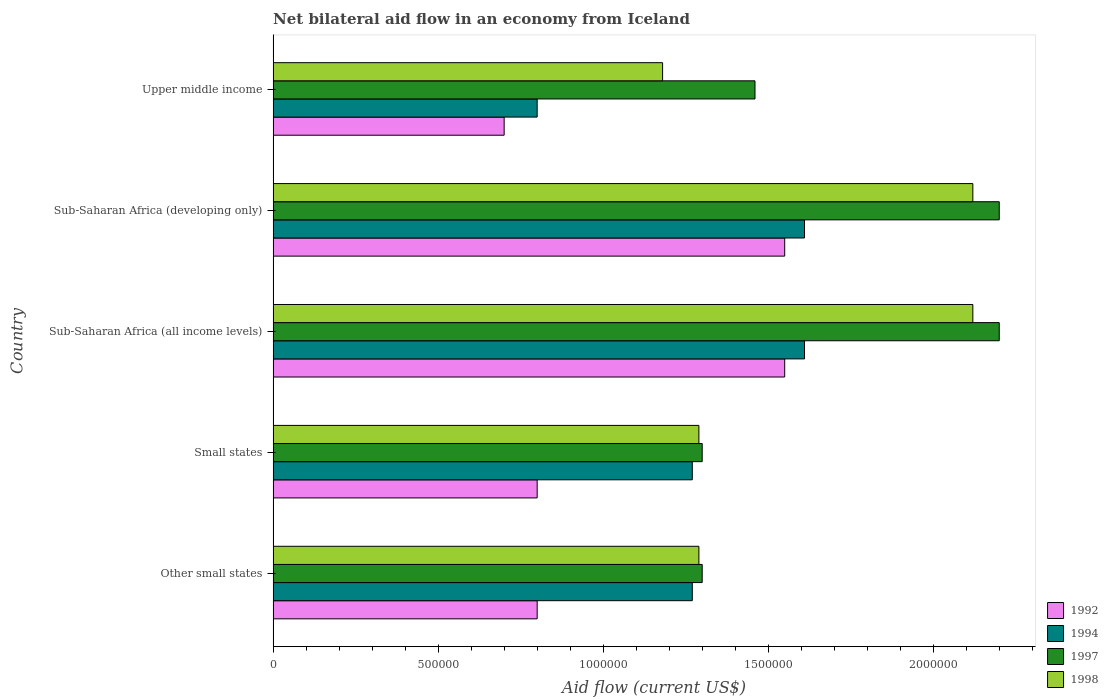How many different coloured bars are there?
Offer a very short reply. 4. How many bars are there on the 2nd tick from the top?
Give a very brief answer. 4. What is the label of the 3rd group of bars from the top?
Provide a succinct answer. Sub-Saharan Africa (all income levels). In how many cases, is the number of bars for a given country not equal to the number of legend labels?
Provide a short and direct response. 0. What is the net bilateral aid flow in 1994 in Upper middle income?
Ensure brevity in your answer.  8.00e+05. Across all countries, what is the maximum net bilateral aid flow in 1994?
Keep it short and to the point. 1.61e+06. Across all countries, what is the minimum net bilateral aid flow in 1997?
Ensure brevity in your answer.  1.30e+06. In which country was the net bilateral aid flow in 1992 maximum?
Make the answer very short. Sub-Saharan Africa (all income levels). In which country was the net bilateral aid flow in 1994 minimum?
Your response must be concise. Upper middle income. What is the total net bilateral aid flow in 1994 in the graph?
Offer a very short reply. 6.56e+06. What is the difference between the net bilateral aid flow in 1998 in Sub-Saharan Africa (developing only) and the net bilateral aid flow in 1992 in Other small states?
Ensure brevity in your answer.  1.32e+06. What is the average net bilateral aid flow in 1997 per country?
Ensure brevity in your answer.  1.69e+06. What is the difference between the net bilateral aid flow in 1997 and net bilateral aid flow in 1992 in Sub-Saharan Africa (all income levels)?
Provide a succinct answer. 6.50e+05. In how many countries, is the net bilateral aid flow in 1992 greater than 2100000 US$?
Make the answer very short. 0. What is the ratio of the net bilateral aid flow in 1992 in Small states to that in Sub-Saharan Africa (all income levels)?
Your response must be concise. 0.52. Is the difference between the net bilateral aid flow in 1997 in Sub-Saharan Africa (all income levels) and Sub-Saharan Africa (developing only) greater than the difference between the net bilateral aid flow in 1992 in Sub-Saharan Africa (all income levels) and Sub-Saharan Africa (developing only)?
Offer a terse response. No. What is the difference between the highest and the second highest net bilateral aid flow in 1994?
Provide a succinct answer. 0. What is the difference between the highest and the lowest net bilateral aid flow in 1992?
Provide a succinct answer. 8.50e+05. In how many countries, is the net bilateral aid flow in 1992 greater than the average net bilateral aid flow in 1992 taken over all countries?
Provide a short and direct response. 2. What does the 3rd bar from the top in Upper middle income represents?
Give a very brief answer. 1994. What does the 1st bar from the bottom in Sub-Saharan Africa (developing only) represents?
Offer a very short reply. 1992. Are all the bars in the graph horizontal?
Ensure brevity in your answer.  Yes. What is the difference between two consecutive major ticks on the X-axis?
Your response must be concise. 5.00e+05. Are the values on the major ticks of X-axis written in scientific E-notation?
Offer a terse response. No. Does the graph contain any zero values?
Provide a succinct answer. No. Does the graph contain grids?
Provide a succinct answer. No. Where does the legend appear in the graph?
Your answer should be compact. Bottom right. How many legend labels are there?
Your answer should be compact. 4. What is the title of the graph?
Your response must be concise. Net bilateral aid flow in an economy from Iceland. Does "1999" appear as one of the legend labels in the graph?
Make the answer very short. No. What is the label or title of the X-axis?
Make the answer very short. Aid flow (current US$). What is the label or title of the Y-axis?
Ensure brevity in your answer.  Country. What is the Aid flow (current US$) in 1992 in Other small states?
Your answer should be very brief. 8.00e+05. What is the Aid flow (current US$) in 1994 in Other small states?
Your answer should be very brief. 1.27e+06. What is the Aid flow (current US$) in 1997 in Other small states?
Make the answer very short. 1.30e+06. What is the Aid flow (current US$) in 1998 in Other small states?
Your answer should be very brief. 1.29e+06. What is the Aid flow (current US$) in 1994 in Small states?
Make the answer very short. 1.27e+06. What is the Aid flow (current US$) of 1997 in Small states?
Keep it short and to the point. 1.30e+06. What is the Aid flow (current US$) in 1998 in Small states?
Offer a terse response. 1.29e+06. What is the Aid flow (current US$) in 1992 in Sub-Saharan Africa (all income levels)?
Keep it short and to the point. 1.55e+06. What is the Aid flow (current US$) in 1994 in Sub-Saharan Africa (all income levels)?
Provide a short and direct response. 1.61e+06. What is the Aid flow (current US$) in 1997 in Sub-Saharan Africa (all income levels)?
Your answer should be very brief. 2.20e+06. What is the Aid flow (current US$) in 1998 in Sub-Saharan Africa (all income levels)?
Keep it short and to the point. 2.12e+06. What is the Aid flow (current US$) in 1992 in Sub-Saharan Africa (developing only)?
Offer a terse response. 1.55e+06. What is the Aid flow (current US$) of 1994 in Sub-Saharan Africa (developing only)?
Your response must be concise. 1.61e+06. What is the Aid flow (current US$) of 1997 in Sub-Saharan Africa (developing only)?
Provide a succinct answer. 2.20e+06. What is the Aid flow (current US$) of 1998 in Sub-Saharan Africa (developing only)?
Offer a terse response. 2.12e+06. What is the Aid flow (current US$) in 1992 in Upper middle income?
Ensure brevity in your answer.  7.00e+05. What is the Aid flow (current US$) of 1994 in Upper middle income?
Keep it short and to the point. 8.00e+05. What is the Aid flow (current US$) of 1997 in Upper middle income?
Give a very brief answer. 1.46e+06. What is the Aid flow (current US$) of 1998 in Upper middle income?
Your response must be concise. 1.18e+06. Across all countries, what is the maximum Aid flow (current US$) in 1992?
Ensure brevity in your answer.  1.55e+06. Across all countries, what is the maximum Aid flow (current US$) in 1994?
Keep it short and to the point. 1.61e+06. Across all countries, what is the maximum Aid flow (current US$) in 1997?
Your answer should be very brief. 2.20e+06. Across all countries, what is the maximum Aid flow (current US$) in 1998?
Keep it short and to the point. 2.12e+06. Across all countries, what is the minimum Aid flow (current US$) in 1994?
Your response must be concise. 8.00e+05. Across all countries, what is the minimum Aid flow (current US$) in 1997?
Give a very brief answer. 1.30e+06. Across all countries, what is the minimum Aid flow (current US$) in 1998?
Offer a very short reply. 1.18e+06. What is the total Aid flow (current US$) of 1992 in the graph?
Offer a terse response. 5.40e+06. What is the total Aid flow (current US$) of 1994 in the graph?
Your answer should be compact. 6.56e+06. What is the total Aid flow (current US$) of 1997 in the graph?
Keep it short and to the point. 8.46e+06. What is the total Aid flow (current US$) in 1998 in the graph?
Provide a succinct answer. 8.00e+06. What is the difference between the Aid flow (current US$) in 1998 in Other small states and that in Small states?
Give a very brief answer. 0. What is the difference between the Aid flow (current US$) in 1992 in Other small states and that in Sub-Saharan Africa (all income levels)?
Your response must be concise. -7.50e+05. What is the difference between the Aid flow (current US$) of 1994 in Other small states and that in Sub-Saharan Africa (all income levels)?
Your answer should be compact. -3.40e+05. What is the difference between the Aid flow (current US$) in 1997 in Other small states and that in Sub-Saharan Africa (all income levels)?
Ensure brevity in your answer.  -9.00e+05. What is the difference between the Aid flow (current US$) in 1998 in Other small states and that in Sub-Saharan Africa (all income levels)?
Give a very brief answer. -8.30e+05. What is the difference between the Aid flow (current US$) in 1992 in Other small states and that in Sub-Saharan Africa (developing only)?
Your answer should be very brief. -7.50e+05. What is the difference between the Aid flow (current US$) in 1997 in Other small states and that in Sub-Saharan Africa (developing only)?
Offer a very short reply. -9.00e+05. What is the difference between the Aid flow (current US$) of 1998 in Other small states and that in Sub-Saharan Africa (developing only)?
Your answer should be compact. -8.30e+05. What is the difference between the Aid flow (current US$) in 1994 in Other small states and that in Upper middle income?
Offer a very short reply. 4.70e+05. What is the difference between the Aid flow (current US$) of 1997 in Other small states and that in Upper middle income?
Offer a very short reply. -1.60e+05. What is the difference between the Aid flow (current US$) in 1992 in Small states and that in Sub-Saharan Africa (all income levels)?
Make the answer very short. -7.50e+05. What is the difference between the Aid flow (current US$) in 1994 in Small states and that in Sub-Saharan Africa (all income levels)?
Give a very brief answer. -3.40e+05. What is the difference between the Aid flow (current US$) of 1997 in Small states and that in Sub-Saharan Africa (all income levels)?
Offer a very short reply. -9.00e+05. What is the difference between the Aid flow (current US$) of 1998 in Small states and that in Sub-Saharan Africa (all income levels)?
Provide a short and direct response. -8.30e+05. What is the difference between the Aid flow (current US$) in 1992 in Small states and that in Sub-Saharan Africa (developing only)?
Give a very brief answer. -7.50e+05. What is the difference between the Aid flow (current US$) of 1997 in Small states and that in Sub-Saharan Africa (developing only)?
Provide a succinct answer. -9.00e+05. What is the difference between the Aid flow (current US$) in 1998 in Small states and that in Sub-Saharan Africa (developing only)?
Your answer should be compact. -8.30e+05. What is the difference between the Aid flow (current US$) of 1994 in Small states and that in Upper middle income?
Your answer should be very brief. 4.70e+05. What is the difference between the Aid flow (current US$) in 1998 in Sub-Saharan Africa (all income levels) and that in Sub-Saharan Africa (developing only)?
Keep it short and to the point. 0. What is the difference between the Aid flow (current US$) of 1992 in Sub-Saharan Africa (all income levels) and that in Upper middle income?
Provide a short and direct response. 8.50e+05. What is the difference between the Aid flow (current US$) of 1994 in Sub-Saharan Africa (all income levels) and that in Upper middle income?
Give a very brief answer. 8.10e+05. What is the difference between the Aid flow (current US$) in 1997 in Sub-Saharan Africa (all income levels) and that in Upper middle income?
Your answer should be very brief. 7.40e+05. What is the difference between the Aid flow (current US$) of 1998 in Sub-Saharan Africa (all income levels) and that in Upper middle income?
Offer a terse response. 9.40e+05. What is the difference between the Aid flow (current US$) of 1992 in Sub-Saharan Africa (developing only) and that in Upper middle income?
Offer a very short reply. 8.50e+05. What is the difference between the Aid flow (current US$) in 1994 in Sub-Saharan Africa (developing only) and that in Upper middle income?
Your response must be concise. 8.10e+05. What is the difference between the Aid flow (current US$) in 1997 in Sub-Saharan Africa (developing only) and that in Upper middle income?
Provide a short and direct response. 7.40e+05. What is the difference between the Aid flow (current US$) in 1998 in Sub-Saharan Africa (developing only) and that in Upper middle income?
Give a very brief answer. 9.40e+05. What is the difference between the Aid flow (current US$) in 1992 in Other small states and the Aid flow (current US$) in 1994 in Small states?
Your answer should be compact. -4.70e+05. What is the difference between the Aid flow (current US$) in 1992 in Other small states and the Aid flow (current US$) in 1997 in Small states?
Your response must be concise. -5.00e+05. What is the difference between the Aid flow (current US$) in 1992 in Other small states and the Aid flow (current US$) in 1998 in Small states?
Your answer should be very brief. -4.90e+05. What is the difference between the Aid flow (current US$) in 1992 in Other small states and the Aid flow (current US$) in 1994 in Sub-Saharan Africa (all income levels)?
Offer a very short reply. -8.10e+05. What is the difference between the Aid flow (current US$) of 1992 in Other small states and the Aid flow (current US$) of 1997 in Sub-Saharan Africa (all income levels)?
Offer a terse response. -1.40e+06. What is the difference between the Aid flow (current US$) in 1992 in Other small states and the Aid flow (current US$) in 1998 in Sub-Saharan Africa (all income levels)?
Offer a very short reply. -1.32e+06. What is the difference between the Aid flow (current US$) in 1994 in Other small states and the Aid flow (current US$) in 1997 in Sub-Saharan Africa (all income levels)?
Give a very brief answer. -9.30e+05. What is the difference between the Aid flow (current US$) in 1994 in Other small states and the Aid flow (current US$) in 1998 in Sub-Saharan Africa (all income levels)?
Make the answer very short. -8.50e+05. What is the difference between the Aid flow (current US$) in 1997 in Other small states and the Aid flow (current US$) in 1998 in Sub-Saharan Africa (all income levels)?
Your response must be concise. -8.20e+05. What is the difference between the Aid flow (current US$) in 1992 in Other small states and the Aid flow (current US$) in 1994 in Sub-Saharan Africa (developing only)?
Give a very brief answer. -8.10e+05. What is the difference between the Aid flow (current US$) in 1992 in Other small states and the Aid flow (current US$) in 1997 in Sub-Saharan Africa (developing only)?
Your response must be concise. -1.40e+06. What is the difference between the Aid flow (current US$) of 1992 in Other small states and the Aid flow (current US$) of 1998 in Sub-Saharan Africa (developing only)?
Ensure brevity in your answer.  -1.32e+06. What is the difference between the Aid flow (current US$) of 1994 in Other small states and the Aid flow (current US$) of 1997 in Sub-Saharan Africa (developing only)?
Provide a short and direct response. -9.30e+05. What is the difference between the Aid flow (current US$) of 1994 in Other small states and the Aid flow (current US$) of 1998 in Sub-Saharan Africa (developing only)?
Give a very brief answer. -8.50e+05. What is the difference between the Aid flow (current US$) of 1997 in Other small states and the Aid flow (current US$) of 1998 in Sub-Saharan Africa (developing only)?
Your response must be concise. -8.20e+05. What is the difference between the Aid flow (current US$) of 1992 in Other small states and the Aid flow (current US$) of 1997 in Upper middle income?
Your response must be concise. -6.60e+05. What is the difference between the Aid flow (current US$) of 1992 in Other small states and the Aid flow (current US$) of 1998 in Upper middle income?
Provide a succinct answer. -3.80e+05. What is the difference between the Aid flow (current US$) in 1994 in Other small states and the Aid flow (current US$) in 1997 in Upper middle income?
Ensure brevity in your answer.  -1.90e+05. What is the difference between the Aid flow (current US$) in 1997 in Other small states and the Aid flow (current US$) in 1998 in Upper middle income?
Ensure brevity in your answer.  1.20e+05. What is the difference between the Aid flow (current US$) in 1992 in Small states and the Aid flow (current US$) in 1994 in Sub-Saharan Africa (all income levels)?
Offer a very short reply. -8.10e+05. What is the difference between the Aid flow (current US$) of 1992 in Small states and the Aid flow (current US$) of 1997 in Sub-Saharan Africa (all income levels)?
Your answer should be compact. -1.40e+06. What is the difference between the Aid flow (current US$) of 1992 in Small states and the Aid flow (current US$) of 1998 in Sub-Saharan Africa (all income levels)?
Ensure brevity in your answer.  -1.32e+06. What is the difference between the Aid flow (current US$) of 1994 in Small states and the Aid flow (current US$) of 1997 in Sub-Saharan Africa (all income levels)?
Offer a terse response. -9.30e+05. What is the difference between the Aid flow (current US$) in 1994 in Small states and the Aid flow (current US$) in 1998 in Sub-Saharan Africa (all income levels)?
Offer a terse response. -8.50e+05. What is the difference between the Aid flow (current US$) of 1997 in Small states and the Aid flow (current US$) of 1998 in Sub-Saharan Africa (all income levels)?
Offer a terse response. -8.20e+05. What is the difference between the Aid flow (current US$) in 1992 in Small states and the Aid flow (current US$) in 1994 in Sub-Saharan Africa (developing only)?
Offer a very short reply. -8.10e+05. What is the difference between the Aid flow (current US$) in 1992 in Small states and the Aid flow (current US$) in 1997 in Sub-Saharan Africa (developing only)?
Make the answer very short. -1.40e+06. What is the difference between the Aid flow (current US$) in 1992 in Small states and the Aid flow (current US$) in 1998 in Sub-Saharan Africa (developing only)?
Provide a short and direct response. -1.32e+06. What is the difference between the Aid flow (current US$) in 1994 in Small states and the Aid flow (current US$) in 1997 in Sub-Saharan Africa (developing only)?
Offer a terse response. -9.30e+05. What is the difference between the Aid flow (current US$) of 1994 in Small states and the Aid flow (current US$) of 1998 in Sub-Saharan Africa (developing only)?
Offer a very short reply. -8.50e+05. What is the difference between the Aid flow (current US$) of 1997 in Small states and the Aid flow (current US$) of 1998 in Sub-Saharan Africa (developing only)?
Ensure brevity in your answer.  -8.20e+05. What is the difference between the Aid flow (current US$) of 1992 in Small states and the Aid flow (current US$) of 1994 in Upper middle income?
Ensure brevity in your answer.  0. What is the difference between the Aid flow (current US$) of 1992 in Small states and the Aid flow (current US$) of 1997 in Upper middle income?
Keep it short and to the point. -6.60e+05. What is the difference between the Aid flow (current US$) in 1992 in Small states and the Aid flow (current US$) in 1998 in Upper middle income?
Make the answer very short. -3.80e+05. What is the difference between the Aid flow (current US$) of 1997 in Small states and the Aid flow (current US$) of 1998 in Upper middle income?
Offer a very short reply. 1.20e+05. What is the difference between the Aid flow (current US$) in 1992 in Sub-Saharan Africa (all income levels) and the Aid flow (current US$) in 1994 in Sub-Saharan Africa (developing only)?
Offer a terse response. -6.00e+04. What is the difference between the Aid flow (current US$) in 1992 in Sub-Saharan Africa (all income levels) and the Aid flow (current US$) in 1997 in Sub-Saharan Africa (developing only)?
Your answer should be compact. -6.50e+05. What is the difference between the Aid flow (current US$) of 1992 in Sub-Saharan Africa (all income levels) and the Aid flow (current US$) of 1998 in Sub-Saharan Africa (developing only)?
Give a very brief answer. -5.70e+05. What is the difference between the Aid flow (current US$) of 1994 in Sub-Saharan Africa (all income levels) and the Aid flow (current US$) of 1997 in Sub-Saharan Africa (developing only)?
Give a very brief answer. -5.90e+05. What is the difference between the Aid flow (current US$) of 1994 in Sub-Saharan Africa (all income levels) and the Aid flow (current US$) of 1998 in Sub-Saharan Africa (developing only)?
Keep it short and to the point. -5.10e+05. What is the difference between the Aid flow (current US$) in 1992 in Sub-Saharan Africa (all income levels) and the Aid flow (current US$) in 1994 in Upper middle income?
Your response must be concise. 7.50e+05. What is the difference between the Aid flow (current US$) in 1992 in Sub-Saharan Africa (all income levels) and the Aid flow (current US$) in 1998 in Upper middle income?
Ensure brevity in your answer.  3.70e+05. What is the difference between the Aid flow (current US$) in 1997 in Sub-Saharan Africa (all income levels) and the Aid flow (current US$) in 1998 in Upper middle income?
Offer a very short reply. 1.02e+06. What is the difference between the Aid flow (current US$) in 1992 in Sub-Saharan Africa (developing only) and the Aid flow (current US$) in 1994 in Upper middle income?
Provide a short and direct response. 7.50e+05. What is the difference between the Aid flow (current US$) in 1992 in Sub-Saharan Africa (developing only) and the Aid flow (current US$) in 1998 in Upper middle income?
Provide a succinct answer. 3.70e+05. What is the difference between the Aid flow (current US$) of 1994 in Sub-Saharan Africa (developing only) and the Aid flow (current US$) of 1997 in Upper middle income?
Make the answer very short. 1.50e+05. What is the difference between the Aid flow (current US$) in 1994 in Sub-Saharan Africa (developing only) and the Aid flow (current US$) in 1998 in Upper middle income?
Ensure brevity in your answer.  4.30e+05. What is the difference between the Aid flow (current US$) of 1997 in Sub-Saharan Africa (developing only) and the Aid flow (current US$) of 1998 in Upper middle income?
Your answer should be very brief. 1.02e+06. What is the average Aid flow (current US$) of 1992 per country?
Offer a terse response. 1.08e+06. What is the average Aid flow (current US$) in 1994 per country?
Make the answer very short. 1.31e+06. What is the average Aid flow (current US$) of 1997 per country?
Offer a terse response. 1.69e+06. What is the average Aid flow (current US$) of 1998 per country?
Keep it short and to the point. 1.60e+06. What is the difference between the Aid flow (current US$) of 1992 and Aid flow (current US$) of 1994 in Other small states?
Ensure brevity in your answer.  -4.70e+05. What is the difference between the Aid flow (current US$) in 1992 and Aid flow (current US$) in 1997 in Other small states?
Your answer should be very brief. -5.00e+05. What is the difference between the Aid flow (current US$) of 1992 and Aid flow (current US$) of 1998 in Other small states?
Your response must be concise. -4.90e+05. What is the difference between the Aid flow (current US$) of 1997 and Aid flow (current US$) of 1998 in Other small states?
Give a very brief answer. 10000. What is the difference between the Aid flow (current US$) in 1992 and Aid flow (current US$) in 1994 in Small states?
Your response must be concise. -4.70e+05. What is the difference between the Aid flow (current US$) of 1992 and Aid flow (current US$) of 1997 in Small states?
Provide a short and direct response. -5.00e+05. What is the difference between the Aid flow (current US$) in 1992 and Aid flow (current US$) in 1998 in Small states?
Your answer should be very brief. -4.90e+05. What is the difference between the Aid flow (current US$) in 1994 and Aid flow (current US$) in 1998 in Small states?
Offer a terse response. -2.00e+04. What is the difference between the Aid flow (current US$) of 1992 and Aid flow (current US$) of 1997 in Sub-Saharan Africa (all income levels)?
Your response must be concise. -6.50e+05. What is the difference between the Aid flow (current US$) in 1992 and Aid flow (current US$) in 1998 in Sub-Saharan Africa (all income levels)?
Ensure brevity in your answer.  -5.70e+05. What is the difference between the Aid flow (current US$) of 1994 and Aid flow (current US$) of 1997 in Sub-Saharan Africa (all income levels)?
Offer a very short reply. -5.90e+05. What is the difference between the Aid flow (current US$) of 1994 and Aid flow (current US$) of 1998 in Sub-Saharan Africa (all income levels)?
Provide a succinct answer. -5.10e+05. What is the difference between the Aid flow (current US$) in 1992 and Aid flow (current US$) in 1994 in Sub-Saharan Africa (developing only)?
Offer a very short reply. -6.00e+04. What is the difference between the Aid flow (current US$) of 1992 and Aid flow (current US$) of 1997 in Sub-Saharan Africa (developing only)?
Provide a succinct answer. -6.50e+05. What is the difference between the Aid flow (current US$) of 1992 and Aid flow (current US$) of 1998 in Sub-Saharan Africa (developing only)?
Keep it short and to the point. -5.70e+05. What is the difference between the Aid flow (current US$) in 1994 and Aid flow (current US$) in 1997 in Sub-Saharan Africa (developing only)?
Provide a short and direct response. -5.90e+05. What is the difference between the Aid flow (current US$) in 1994 and Aid flow (current US$) in 1998 in Sub-Saharan Africa (developing only)?
Offer a terse response. -5.10e+05. What is the difference between the Aid flow (current US$) of 1997 and Aid flow (current US$) of 1998 in Sub-Saharan Africa (developing only)?
Your response must be concise. 8.00e+04. What is the difference between the Aid flow (current US$) in 1992 and Aid flow (current US$) in 1997 in Upper middle income?
Offer a terse response. -7.60e+05. What is the difference between the Aid flow (current US$) of 1992 and Aid flow (current US$) of 1998 in Upper middle income?
Your response must be concise. -4.80e+05. What is the difference between the Aid flow (current US$) of 1994 and Aid flow (current US$) of 1997 in Upper middle income?
Offer a very short reply. -6.60e+05. What is the difference between the Aid flow (current US$) of 1994 and Aid flow (current US$) of 1998 in Upper middle income?
Keep it short and to the point. -3.80e+05. What is the ratio of the Aid flow (current US$) in 1992 in Other small states to that in Small states?
Offer a terse response. 1. What is the ratio of the Aid flow (current US$) of 1997 in Other small states to that in Small states?
Your response must be concise. 1. What is the ratio of the Aid flow (current US$) of 1998 in Other small states to that in Small states?
Your response must be concise. 1. What is the ratio of the Aid flow (current US$) of 1992 in Other small states to that in Sub-Saharan Africa (all income levels)?
Offer a terse response. 0.52. What is the ratio of the Aid flow (current US$) in 1994 in Other small states to that in Sub-Saharan Africa (all income levels)?
Offer a terse response. 0.79. What is the ratio of the Aid flow (current US$) in 1997 in Other small states to that in Sub-Saharan Africa (all income levels)?
Your answer should be very brief. 0.59. What is the ratio of the Aid flow (current US$) of 1998 in Other small states to that in Sub-Saharan Africa (all income levels)?
Offer a terse response. 0.61. What is the ratio of the Aid flow (current US$) in 1992 in Other small states to that in Sub-Saharan Africa (developing only)?
Make the answer very short. 0.52. What is the ratio of the Aid flow (current US$) in 1994 in Other small states to that in Sub-Saharan Africa (developing only)?
Keep it short and to the point. 0.79. What is the ratio of the Aid flow (current US$) in 1997 in Other small states to that in Sub-Saharan Africa (developing only)?
Offer a very short reply. 0.59. What is the ratio of the Aid flow (current US$) in 1998 in Other small states to that in Sub-Saharan Africa (developing only)?
Offer a very short reply. 0.61. What is the ratio of the Aid flow (current US$) in 1994 in Other small states to that in Upper middle income?
Ensure brevity in your answer.  1.59. What is the ratio of the Aid flow (current US$) in 1997 in Other small states to that in Upper middle income?
Your answer should be very brief. 0.89. What is the ratio of the Aid flow (current US$) in 1998 in Other small states to that in Upper middle income?
Make the answer very short. 1.09. What is the ratio of the Aid flow (current US$) in 1992 in Small states to that in Sub-Saharan Africa (all income levels)?
Your answer should be very brief. 0.52. What is the ratio of the Aid flow (current US$) of 1994 in Small states to that in Sub-Saharan Africa (all income levels)?
Offer a terse response. 0.79. What is the ratio of the Aid flow (current US$) in 1997 in Small states to that in Sub-Saharan Africa (all income levels)?
Ensure brevity in your answer.  0.59. What is the ratio of the Aid flow (current US$) in 1998 in Small states to that in Sub-Saharan Africa (all income levels)?
Ensure brevity in your answer.  0.61. What is the ratio of the Aid flow (current US$) in 1992 in Small states to that in Sub-Saharan Africa (developing only)?
Provide a succinct answer. 0.52. What is the ratio of the Aid flow (current US$) of 1994 in Small states to that in Sub-Saharan Africa (developing only)?
Keep it short and to the point. 0.79. What is the ratio of the Aid flow (current US$) of 1997 in Small states to that in Sub-Saharan Africa (developing only)?
Your response must be concise. 0.59. What is the ratio of the Aid flow (current US$) in 1998 in Small states to that in Sub-Saharan Africa (developing only)?
Your response must be concise. 0.61. What is the ratio of the Aid flow (current US$) of 1992 in Small states to that in Upper middle income?
Your response must be concise. 1.14. What is the ratio of the Aid flow (current US$) of 1994 in Small states to that in Upper middle income?
Your answer should be compact. 1.59. What is the ratio of the Aid flow (current US$) of 1997 in Small states to that in Upper middle income?
Ensure brevity in your answer.  0.89. What is the ratio of the Aid flow (current US$) in 1998 in Small states to that in Upper middle income?
Provide a short and direct response. 1.09. What is the ratio of the Aid flow (current US$) of 1992 in Sub-Saharan Africa (all income levels) to that in Sub-Saharan Africa (developing only)?
Offer a terse response. 1. What is the ratio of the Aid flow (current US$) in 1998 in Sub-Saharan Africa (all income levels) to that in Sub-Saharan Africa (developing only)?
Make the answer very short. 1. What is the ratio of the Aid flow (current US$) in 1992 in Sub-Saharan Africa (all income levels) to that in Upper middle income?
Your response must be concise. 2.21. What is the ratio of the Aid flow (current US$) in 1994 in Sub-Saharan Africa (all income levels) to that in Upper middle income?
Make the answer very short. 2.01. What is the ratio of the Aid flow (current US$) of 1997 in Sub-Saharan Africa (all income levels) to that in Upper middle income?
Provide a short and direct response. 1.51. What is the ratio of the Aid flow (current US$) in 1998 in Sub-Saharan Africa (all income levels) to that in Upper middle income?
Provide a short and direct response. 1.8. What is the ratio of the Aid flow (current US$) of 1992 in Sub-Saharan Africa (developing only) to that in Upper middle income?
Make the answer very short. 2.21. What is the ratio of the Aid flow (current US$) in 1994 in Sub-Saharan Africa (developing only) to that in Upper middle income?
Provide a short and direct response. 2.01. What is the ratio of the Aid flow (current US$) in 1997 in Sub-Saharan Africa (developing only) to that in Upper middle income?
Ensure brevity in your answer.  1.51. What is the ratio of the Aid flow (current US$) in 1998 in Sub-Saharan Africa (developing only) to that in Upper middle income?
Your answer should be very brief. 1.8. What is the difference between the highest and the second highest Aid flow (current US$) in 1994?
Provide a short and direct response. 0. What is the difference between the highest and the second highest Aid flow (current US$) in 1998?
Your response must be concise. 0. What is the difference between the highest and the lowest Aid flow (current US$) of 1992?
Give a very brief answer. 8.50e+05. What is the difference between the highest and the lowest Aid flow (current US$) of 1994?
Ensure brevity in your answer.  8.10e+05. What is the difference between the highest and the lowest Aid flow (current US$) in 1998?
Ensure brevity in your answer.  9.40e+05. 